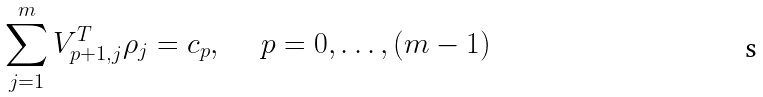Convert formula to latex. <formula><loc_0><loc_0><loc_500><loc_500>\sum _ { j = 1 } ^ { m } V ^ { T } _ { p + 1 , j } \rho _ { j } = c _ { p } , \ \quad p = 0 , \dots , ( m - 1 )</formula> 